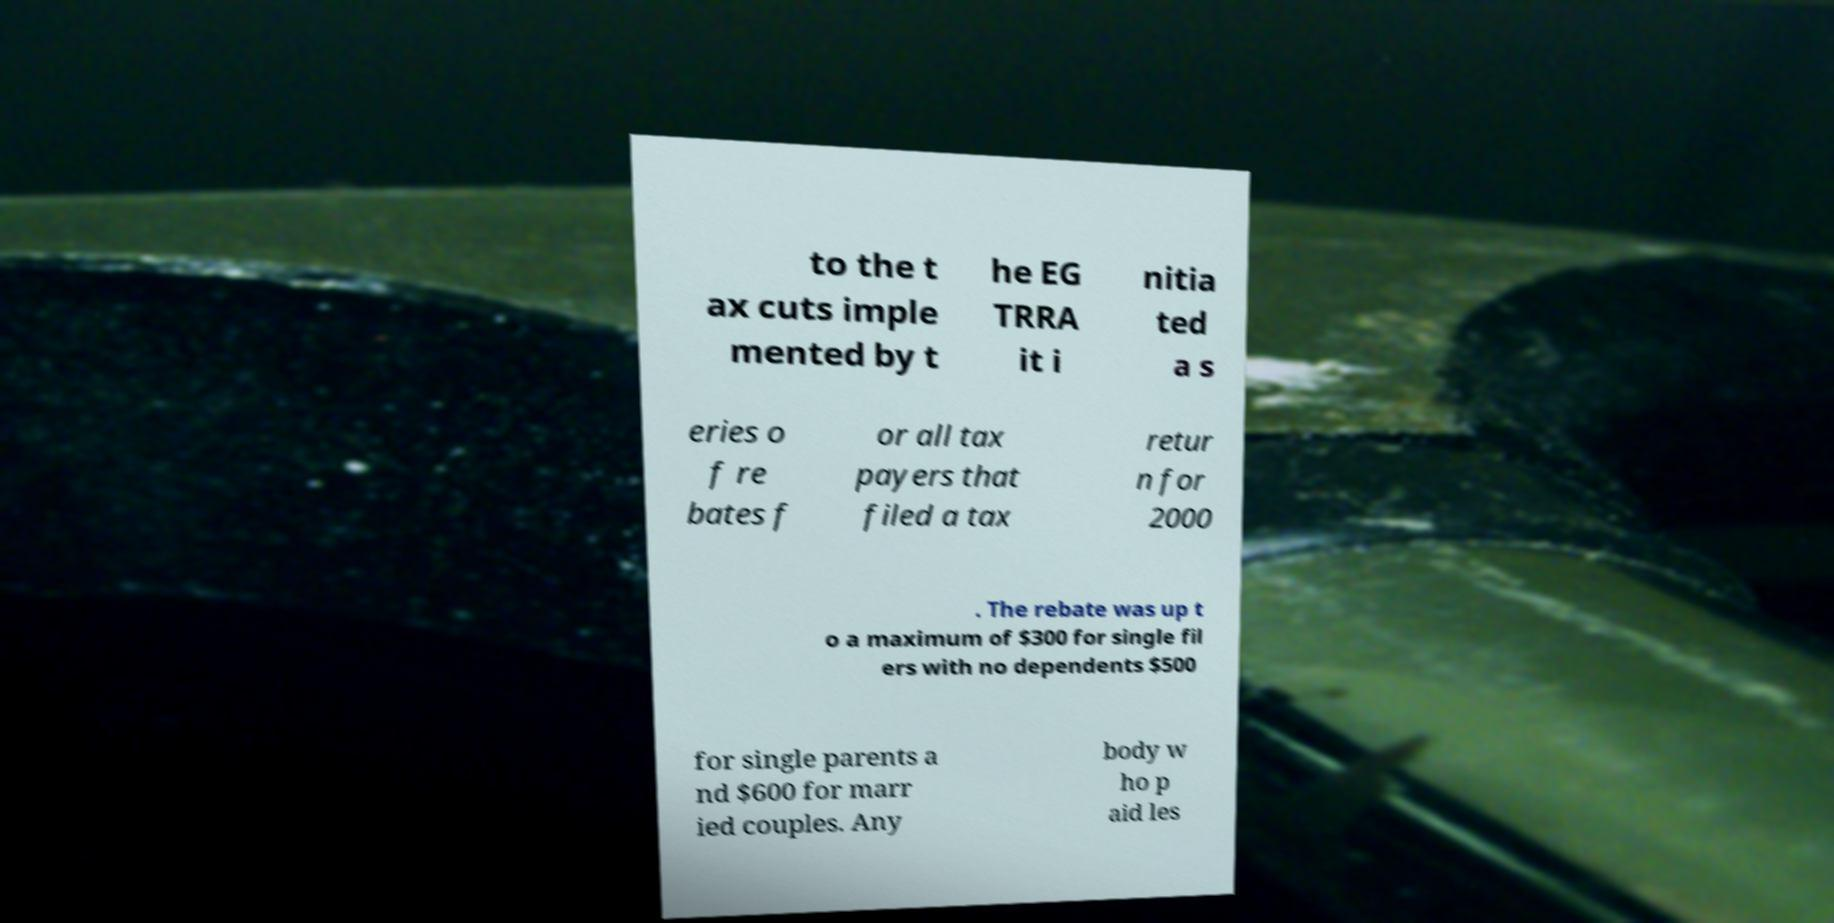Please identify and transcribe the text found in this image. to the t ax cuts imple mented by t he EG TRRA it i nitia ted a s eries o f re bates f or all tax payers that filed a tax retur n for 2000 . The rebate was up t o a maximum of $300 for single fil ers with no dependents $500 for single parents a nd $600 for marr ied couples. Any body w ho p aid les 